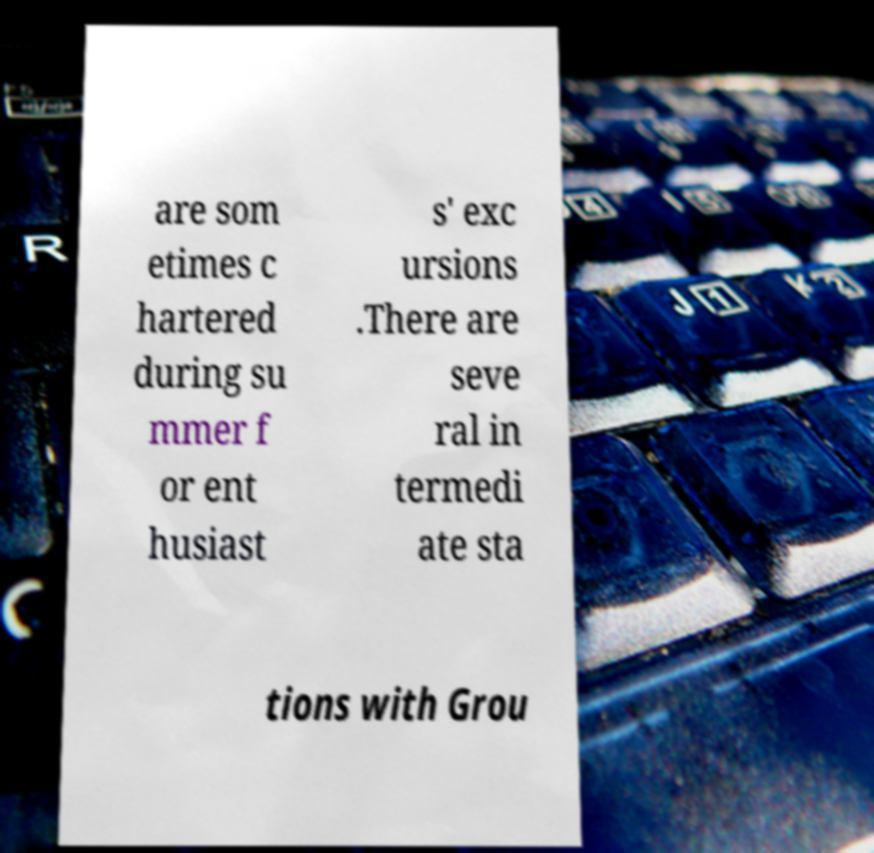I need the written content from this picture converted into text. Can you do that? are som etimes c hartered during su mmer f or ent husiast s' exc ursions .There are seve ral in termedi ate sta tions with Grou 